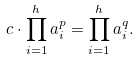<formula> <loc_0><loc_0><loc_500><loc_500>c \cdot \prod _ { i = 1 } ^ { h } a _ { i } ^ { p } = \prod _ { i = 1 } ^ { h } a _ { i } ^ { q } .</formula> 